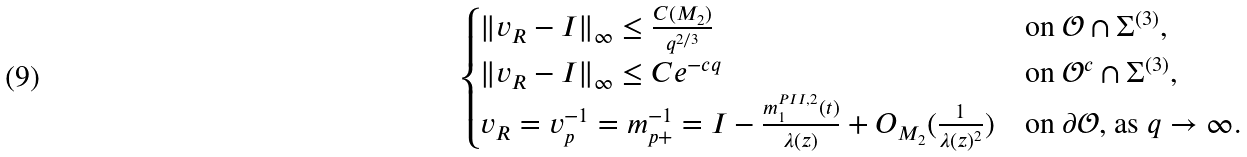Convert formula to latex. <formula><loc_0><loc_0><loc_500><loc_500>\begin{cases} \| v _ { R } - I \| _ { \infty } \leq \frac { C ( M _ { 2 } ) } { q ^ { 2 / 3 } } & \text {on $\mathcal{O} \cap \Sigma^{(3)}$} , \\ \| v _ { R } - I \| _ { \infty } \leq C e ^ { - c q } & \text {on $\mathcal{O}^{c} \cap \Sigma^{(3)}$} , \\ v _ { R } = v _ { p } ^ { - 1 } = m _ { p + } ^ { - 1 } = I - \frac { m ^ { P I I , 2 } _ { 1 } ( t ) } { \lambda ( z ) } + O _ { M _ { 2 } } ( \frac { 1 } { \lambda ( z ) ^ { 2 } } ) & \text {on $\partial \mathcal{O}$, as $q\to\infty$.} \end{cases}</formula> 